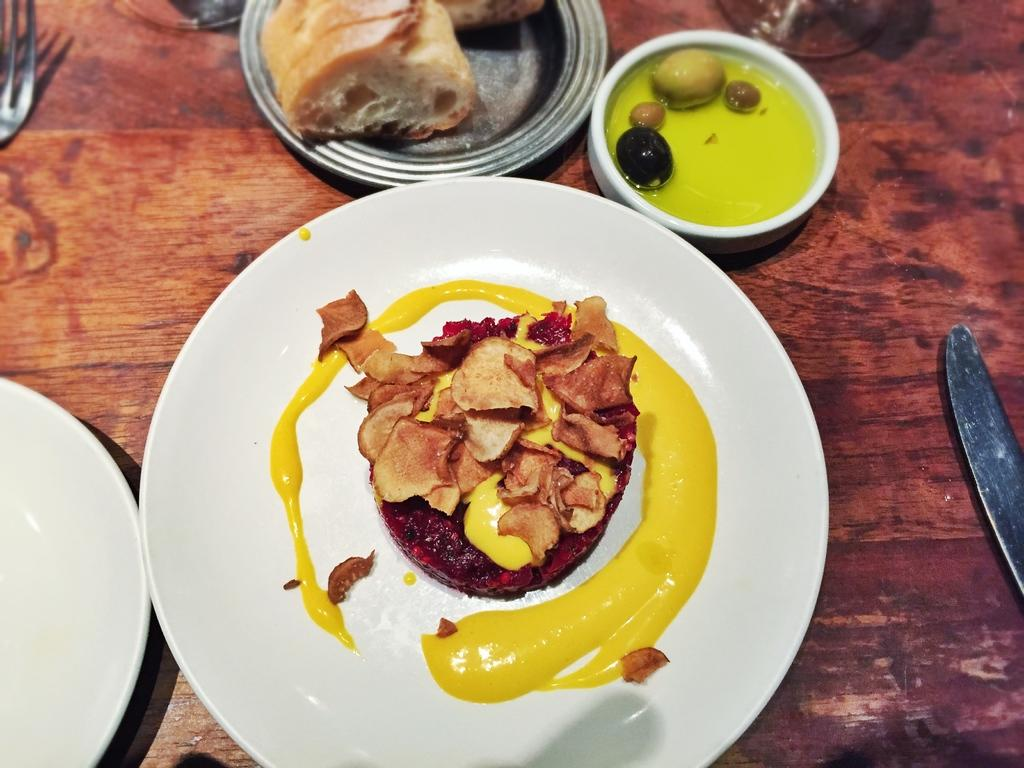What type of surface is visible in the image? There is a wooden surface in the image. What utensils can be seen on the wooden surface? A knife and a fork are present on the wooden surface. What type of containers are on the wooden surface? There are bowls and plates on the wooden surface. What can be inferred about the purpose of the wooden surface? The presence of utensils, bowls, plates, and food items suggests that the wooden surface is likely a table or countertop for serving or preparing food. What type of underwear is visible in the image? There is no underwear present in the image. Can you tell me how many grapes are on the plate in the image? The image does not specify the type of food items, so it is impossible to determine if there are any grapes present. 